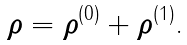Convert formula to latex. <formula><loc_0><loc_0><loc_500><loc_500>\text {\boldmath$\rho$} = \text {\boldmath$\rho$} ^ { ( 0 ) } + \text {\boldmath$\rho$} ^ { ( 1 ) } .</formula> 